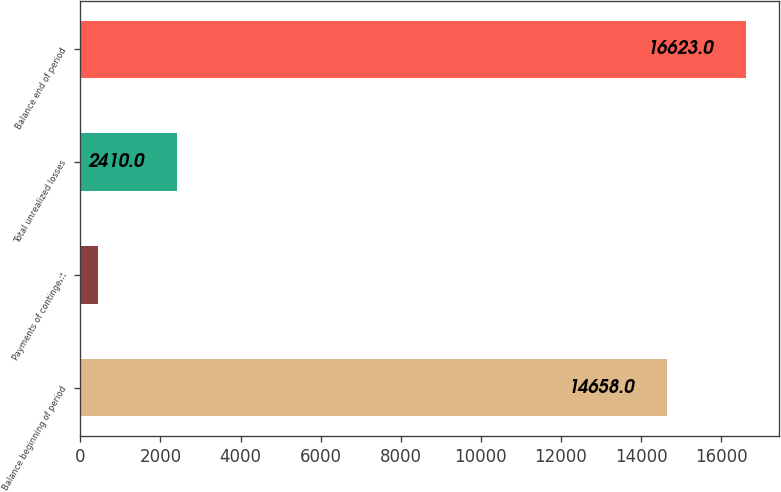Convert chart to OTSL. <chart><loc_0><loc_0><loc_500><loc_500><bar_chart><fcel>Balance beginning of period<fcel>Payments of contingent<fcel>Total unrealized losses<fcel>Balance end of period<nl><fcel>14658<fcel>445<fcel>2410<fcel>16623<nl></chart> 